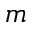<formula> <loc_0><loc_0><loc_500><loc_500>m</formula> 